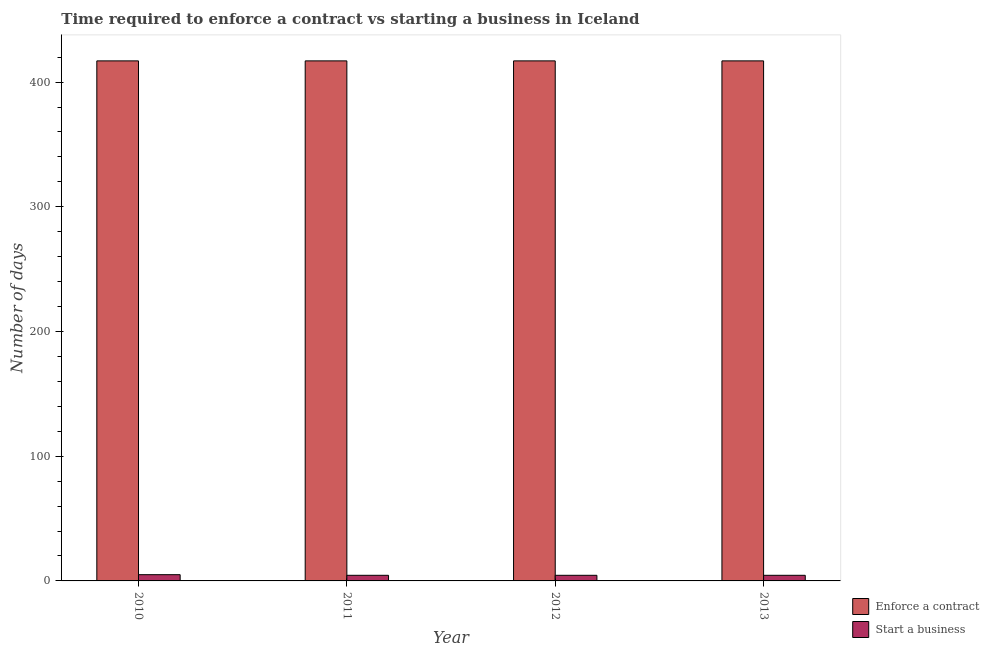How many different coloured bars are there?
Offer a very short reply. 2. How many groups of bars are there?
Keep it short and to the point. 4. How many bars are there on the 4th tick from the left?
Make the answer very short. 2. How many bars are there on the 3rd tick from the right?
Your response must be concise. 2. What is the label of the 1st group of bars from the left?
Offer a terse response. 2010. In how many cases, is the number of bars for a given year not equal to the number of legend labels?
Provide a short and direct response. 0. What is the number of days to enforece a contract in 2010?
Provide a succinct answer. 417. Across all years, what is the maximum number of days to enforece a contract?
Your answer should be very brief. 417. In which year was the number of days to start a business maximum?
Provide a short and direct response. 2010. What is the total number of days to enforece a contract in the graph?
Offer a very short reply. 1668. What is the average number of days to enforece a contract per year?
Keep it short and to the point. 417. In the year 2012, what is the difference between the number of days to start a business and number of days to enforece a contract?
Provide a short and direct response. 0. In how many years, is the number of days to enforece a contract greater than 160 days?
Offer a very short reply. 4. What is the ratio of the number of days to start a business in 2011 to that in 2012?
Keep it short and to the point. 1. Is the number of days to enforece a contract in 2010 less than that in 2012?
Ensure brevity in your answer.  No. Is the difference between the number of days to start a business in 2010 and 2011 greater than the difference between the number of days to enforece a contract in 2010 and 2011?
Provide a short and direct response. No. What is the difference between the highest and the lowest number of days to start a business?
Offer a very short reply. 0.5. In how many years, is the number of days to start a business greater than the average number of days to start a business taken over all years?
Provide a succinct answer. 1. What does the 2nd bar from the left in 2013 represents?
Ensure brevity in your answer.  Start a business. What does the 1st bar from the right in 2010 represents?
Provide a succinct answer. Start a business. How many bars are there?
Give a very brief answer. 8. How many years are there in the graph?
Make the answer very short. 4. Are the values on the major ticks of Y-axis written in scientific E-notation?
Ensure brevity in your answer.  No. Does the graph contain grids?
Your answer should be very brief. No. What is the title of the graph?
Give a very brief answer. Time required to enforce a contract vs starting a business in Iceland. What is the label or title of the X-axis?
Provide a short and direct response. Year. What is the label or title of the Y-axis?
Offer a terse response. Number of days. What is the Number of days of Enforce a contract in 2010?
Offer a very short reply. 417. What is the Number of days of Start a business in 2010?
Give a very brief answer. 5. What is the Number of days of Enforce a contract in 2011?
Provide a short and direct response. 417. What is the Number of days of Start a business in 2011?
Provide a succinct answer. 4.5. What is the Number of days of Enforce a contract in 2012?
Your response must be concise. 417. What is the Number of days of Start a business in 2012?
Provide a succinct answer. 4.5. What is the Number of days of Enforce a contract in 2013?
Ensure brevity in your answer.  417. Across all years, what is the maximum Number of days in Enforce a contract?
Keep it short and to the point. 417. Across all years, what is the minimum Number of days in Enforce a contract?
Make the answer very short. 417. What is the total Number of days in Enforce a contract in the graph?
Give a very brief answer. 1668. What is the total Number of days in Start a business in the graph?
Ensure brevity in your answer.  18.5. What is the difference between the Number of days of Start a business in 2010 and that in 2011?
Provide a succinct answer. 0.5. What is the difference between the Number of days in Enforce a contract in 2010 and that in 2013?
Make the answer very short. 0. What is the difference between the Number of days in Enforce a contract in 2011 and that in 2012?
Your response must be concise. 0. What is the difference between the Number of days of Enforce a contract in 2011 and that in 2013?
Ensure brevity in your answer.  0. What is the difference between the Number of days of Start a business in 2011 and that in 2013?
Keep it short and to the point. 0. What is the difference between the Number of days of Enforce a contract in 2010 and the Number of days of Start a business in 2011?
Your response must be concise. 412.5. What is the difference between the Number of days in Enforce a contract in 2010 and the Number of days in Start a business in 2012?
Offer a terse response. 412.5. What is the difference between the Number of days in Enforce a contract in 2010 and the Number of days in Start a business in 2013?
Provide a short and direct response. 412.5. What is the difference between the Number of days of Enforce a contract in 2011 and the Number of days of Start a business in 2012?
Your response must be concise. 412.5. What is the difference between the Number of days of Enforce a contract in 2011 and the Number of days of Start a business in 2013?
Your response must be concise. 412.5. What is the difference between the Number of days in Enforce a contract in 2012 and the Number of days in Start a business in 2013?
Offer a terse response. 412.5. What is the average Number of days in Enforce a contract per year?
Your answer should be very brief. 417. What is the average Number of days in Start a business per year?
Your answer should be very brief. 4.62. In the year 2010, what is the difference between the Number of days in Enforce a contract and Number of days in Start a business?
Offer a terse response. 412. In the year 2011, what is the difference between the Number of days in Enforce a contract and Number of days in Start a business?
Provide a succinct answer. 412.5. In the year 2012, what is the difference between the Number of days in Enforce a contract and Number of days in Start a business?
Your answer should be very brief. 412.5. In the year 2013, what is the difference between the Number of days of Enforce a contract and Number of days of Start a business?
Your response must be concise. 412.5. What is the ratio of the Number of days in Start a business in 2010 to that in 2012?
Provide a short and direct response. 1.11. What is the ratio of the Number of days of Enforce a contract in 2010 to that in 2013?
Offer a terse response. 1. What is the ratio of the Number of days in Start a business in 2011 to that in 2012?
Provide a short and direct response. 1. What is the ratio of the Number of days of Start a business in 2011 to that in 2013?
Make the answer very short. 1. What is the ratio of the Number of days in Enforce a contract in 2012 to that in 2013?
Provide a succinct answer. 1. What is the ratio of the Number of days of Start a business in 2012 to that in 2013?
Offer a very short reply. 1. 